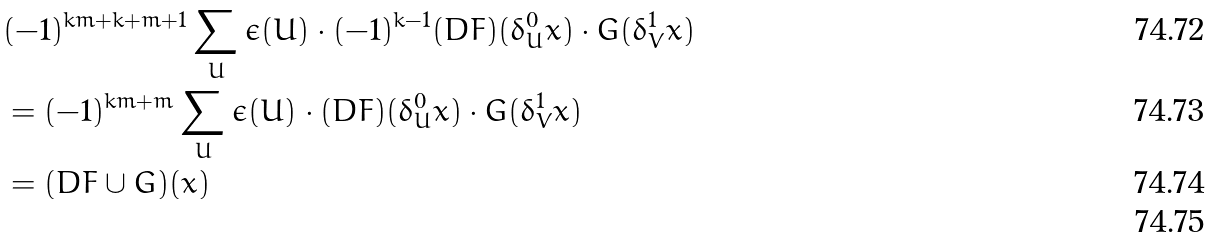<formula> <loc_0><loc_0><loc_500><loc_500>& ( - 1 ) ^ { k m + k + m + 1 } \sum _ { U } \epsilon ( U ) \cdot ( - 1 ) ^ { k - 1 } ( D F ) ( \delta ^ { 0 } _ { U } x ) \cdot G ( \delta ^ { 1 } _ { V } x ) \\ & = ( - 1 ) ^ { k m + m } \sum _ { U } \epsilon ( U ) \cdot ( D F ) ( \delta ^ { 0 } _ { U } x ) \cdot G ( \delta ^ { 1 } _ { V } x ) \\ & = ( D F \cup G ) ( x ) \\</formula> 